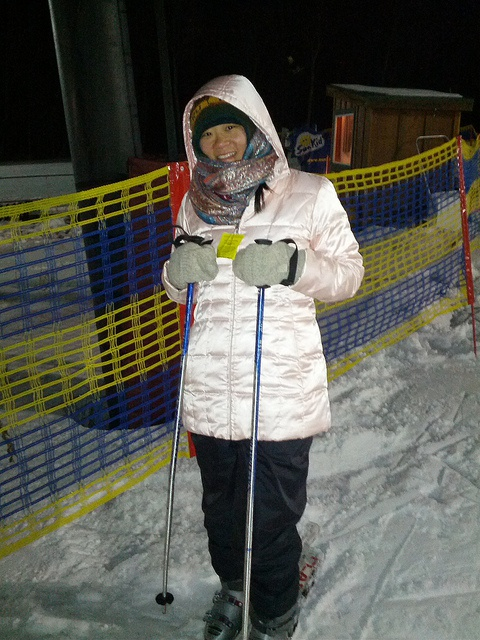Describe the objects in this image and their specific colors. I can see people in black, lightgray, darkgray, and gray tones and skis in black, gray, and maroon tones in this image. 